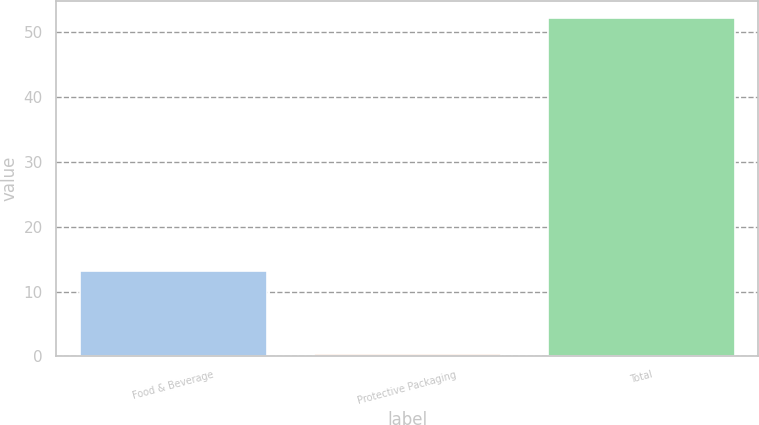<chart> <loc_0><loc_0><loc_500><loc_500><bar_chart><fcel>Food & Beverage<fcel>Protective Packaging<fcel>Total<nl><fcel>13.1<fcel>0.4<fcel>52.2<nl></chart> 